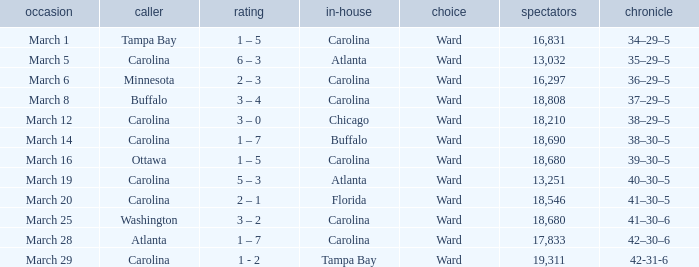What is the Record when Buffalo is at Home? 38–30–5. 